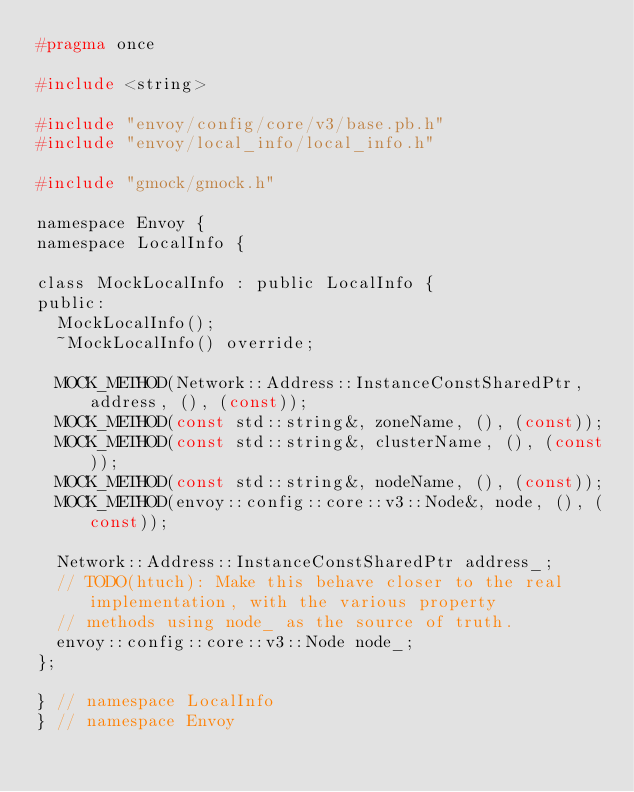Convert code to text. <code><loc_0><loc_0><loc_500><loc_500><_C_>#pragma once

#include <string>

#include "envoy/config/core/v3/base.pb.h"
#include "envoy/local_info/local_info.h"

#include "gmock/gmock.h"

namespace Envoy {
namespace LocalInfo {

class MockLocalInfo : public LocalInfo {
public:
  MockLocalInfo();
  ~MockLocalInfo() override;

  MOCK_METHOD(Network::Address::InstanceConstSharedPtr, address, (), (const));
  MOCK_METHOD(const std::string&, zoneName, (), (const));
  MOCK_METHOD(const std::string&, clusterName, (), (const));
  MOCK_METHOD(const std::string&, nodeName, (), (const));
  MOCK_METHOD(envoy::config::core::v3::Node&, node, (), (const));

  Network::Address::InstanceConstSharedPtr address_;
  // TODO(htuch): Make this behave closer to the real implementation, with the various property
  // methods using node_ as the source of truth.
  envoy::config::core::v3::Node node_;
};

} // namespace LocalInfo
} // namespace Envoy
</code> 